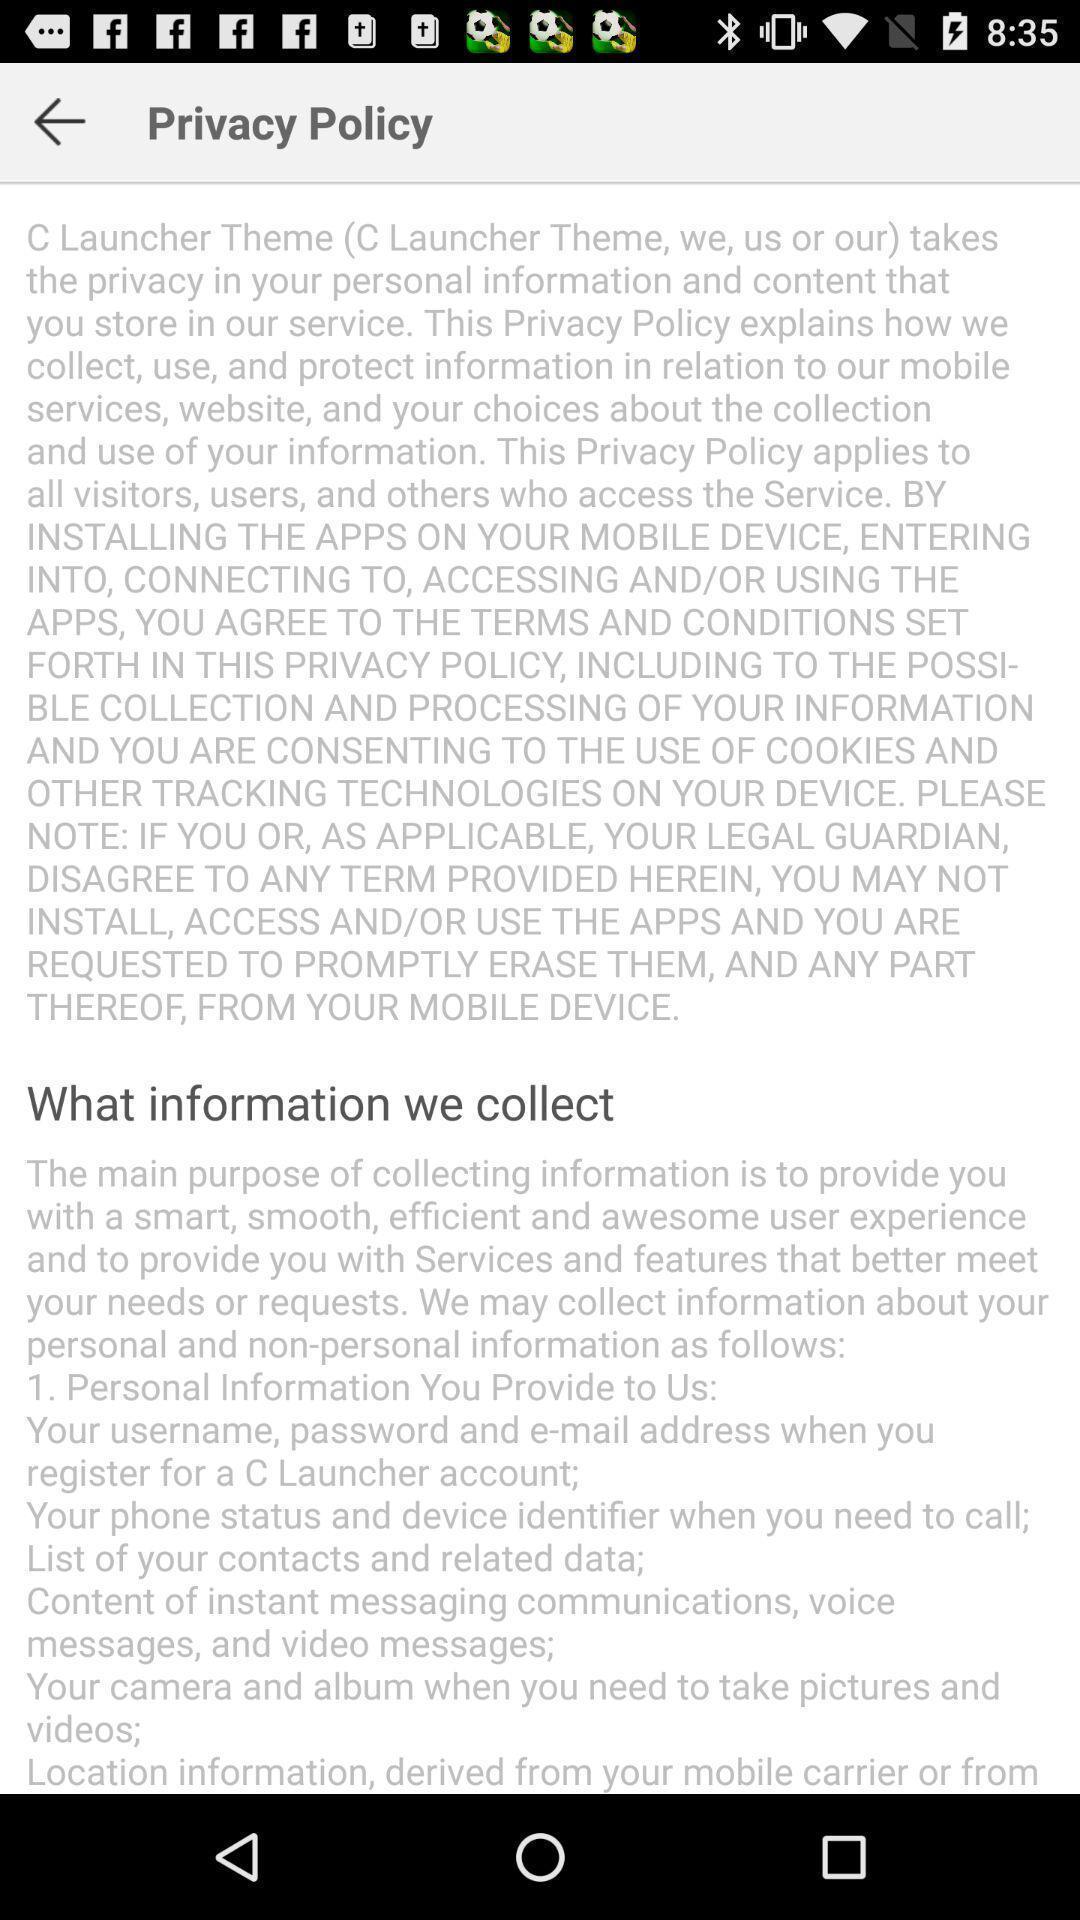Provide a textual representation of this image. Page showing the content about privacy policy and the information. 